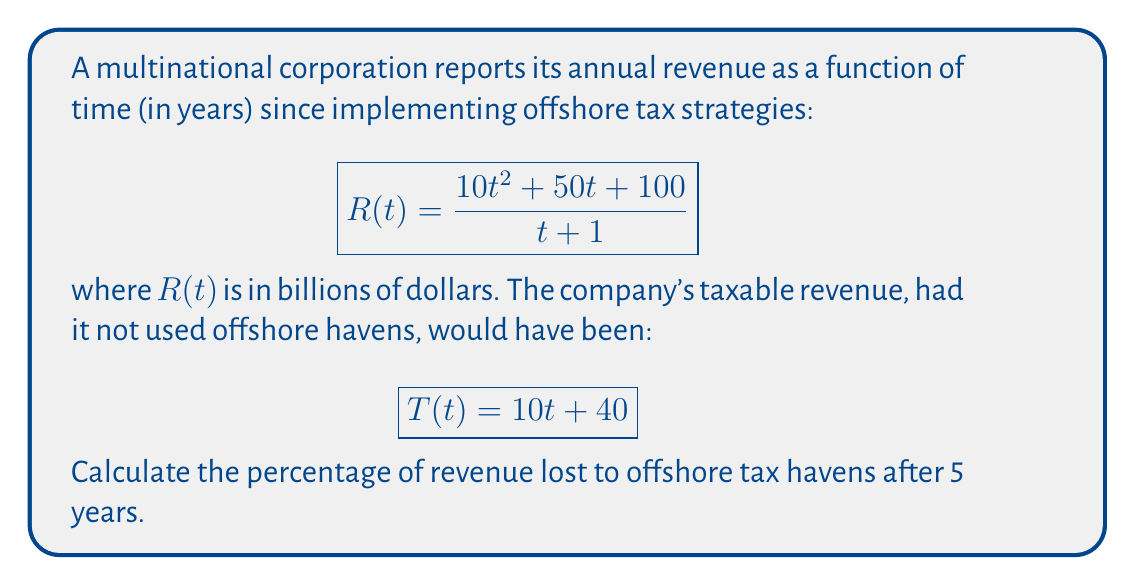Could you help me with this problem? To solve this problem, we'll follow these steps:

1) Calculate the reported revenue R(5):
   $$R(5) = \frac{10(5)^2 + 50(5) + 100}{5 + 1} = \frac{250 + 250 + 100}{6} = \frac{600}{6} = 100$$ billion dollars

2) Calculate the taxable revenue T(5):
   $$T(5) = 10(5) + 40 = 50 + 40 = 90$$ billion dollars

3) Calculate the difference between taxable and reported revenue:
   $$T(5) - R(5) = 90 - 100 = -10$$ billion dollars

4) Calculate the percentage of revenue lost:
   $$\text{Percentage Lost} = \frac{\text{Difference}}{\text{Taxable Revenue}} \times 100\%$$
   $$= \frac{-10}{90} \times 100\% = -11.11\%$$

The negative percentage indicates that the reported revenue is actually higher than the taxable revenue. This means the company is not losing revenue to offshore tax havens, but rather gaining 11.11% more than it would have without these strategies.
Answer: -11.11% 